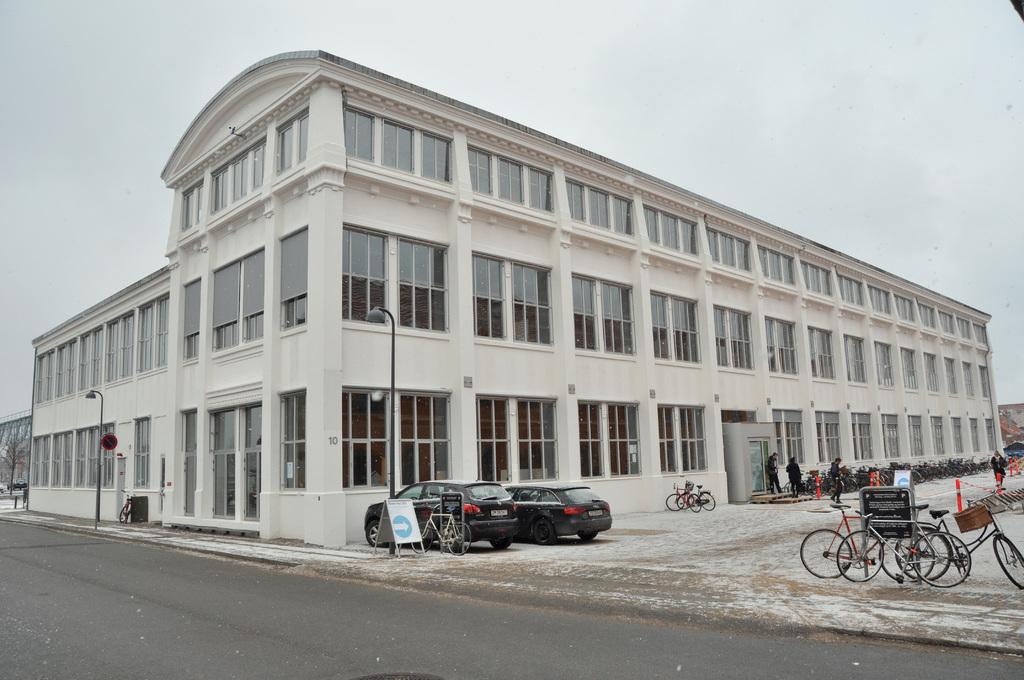What types of objects can be seen in the image? There are vehicles and light poles visible in the image. What are the people in the image doing? There are people walking in the image. What type of structures can be seen in the image? There are buildings in the image. What feature can be observed on some of the buildings? There are glass windows in the image. What is the color of the sky in the image? The sky is in white color in the image. Where is the box located in the image? There is no box present in the image. What type of prison can be seen in the image? There is no prison present in the image. 